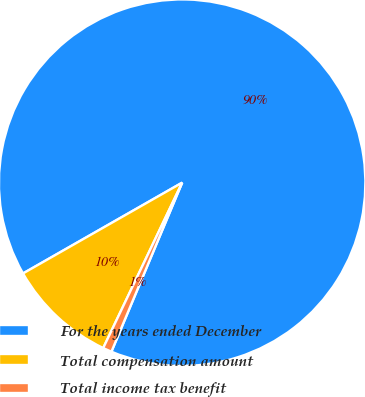Convert chart to OTSL. <chart><loc_0><loc_0><loc_500><loc_500><pie_chart><fcel>For the years ended December<fcel>Total compensation amount<fcel>Total income tax benefit<nl><fcel>89.56%<fcel>9.66%<fcel>0.78%<nl></chart> 